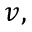<formula> <loc_0><loc_0><loc_500><loc_500>v ,</formula> 